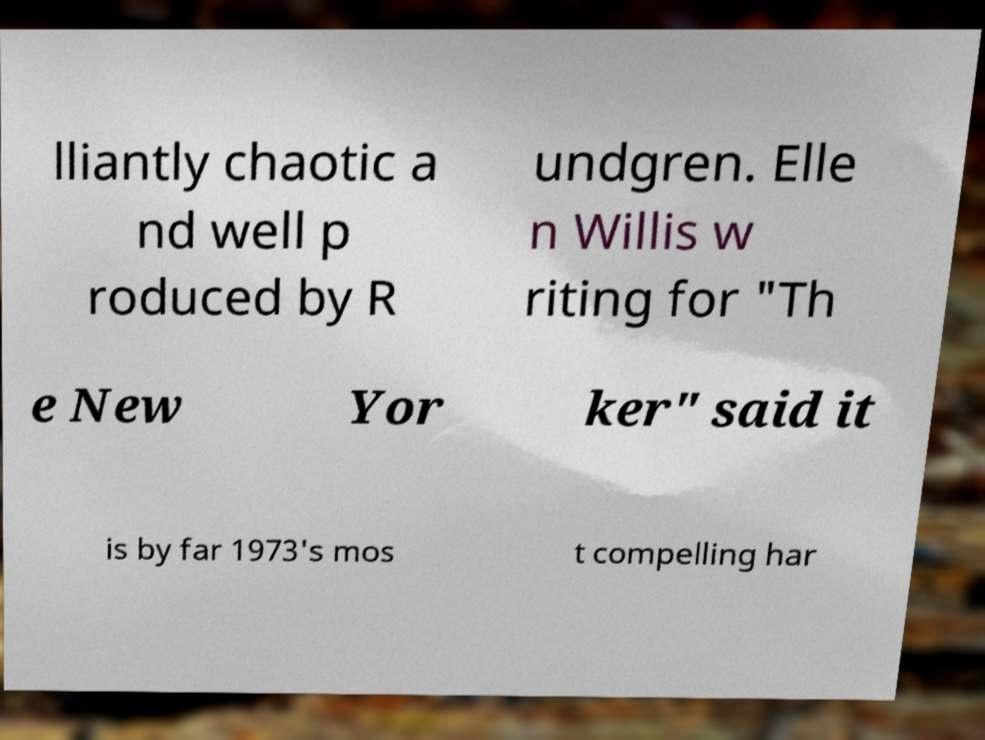Please identify and transcribe the text found in this image. lliantly chaotic a nd well p roduced by R undgren. Elle n Willis w riting for "Th e New Yor ker" said it is by far 1973's mos t compelling har 